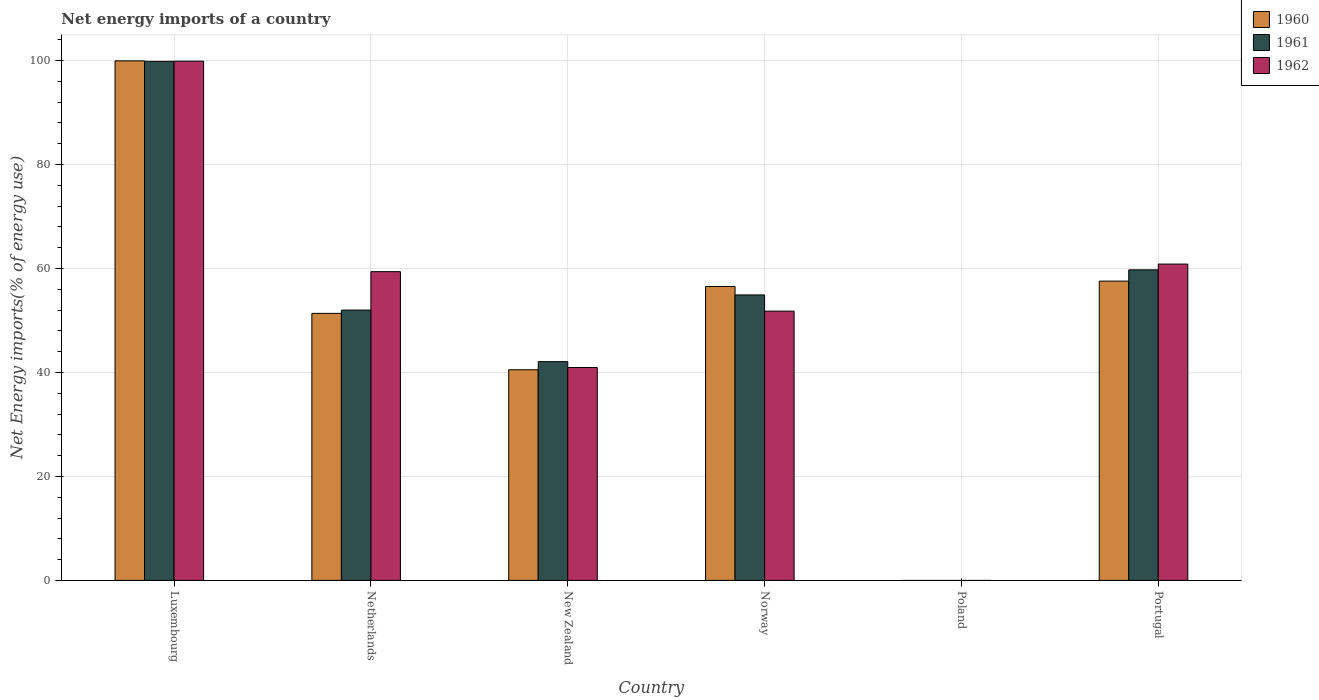How many different coloured bars are there?
Offer a very short reply. 3. Are the number of bars per tick equal to the number of legend labels?
Offer a terse response. No. How many bars are there on the 3rd tick from the left?
Your answer should be compact. 3. What is the label of the 1st group of bars from the left?
Offer a terse response. Luxembourg. In how many cases, is the number of bars for a given country not equal to the number of legend labels?
Your answer should be compact. 1. What is the net energy imports in 1961 in Netherlands?
Make the answer very short. 52. Across all countries, what is the maximum net energy imports in 1962?
Your response must be concise. 99.88. In which country was the net energy imports in 1961 maximum?
Your answer should be very brief. Luxembourg. What is the total net energy imports in 1962 in the graph?
Provide a succinct answer. 312.88. What is the difference between the net energy imports in 1961 in Netherlands and that in Portugal?
Give a very brief answer. -7.74. What is the difference between the net energy imports in 1962 in Norway and the net energy imports in 1961 in Portugal?
Provide a short and direct response. -7.94. What is the average net energy imports in 1961 per country?
Give a very brief answer. 51.43. What is the difference between the net energy imports of/in 1960 and net energy imports of/in 1961 in New Zealand?
Ensure brevity in your answer.  -1.56. In how many countries, is the net energy imports in 1961 greater than 32 %?
Keep it short and to the point. 5. What is the ratio of the net energy imports in 1962 in Luxembourg to that in Portugal?
Your response must be concise. 1.64. What is the difference between the highest and the second highest net energy imports in 1960?
Provide a short and direct response. -1.03. What is the difference between the highest and the lowest net energy imports in 1961?
Provide a succinct answer. 99.85. Is the sum of the net energy imports in 1962 in Luxembourg and Netherlands greater than the maximum net energy imports in 1960 across all countries?
Make the answer very short. Yes. How many countries are there in the graph?
Give a very brief answer. 6. What is the difference between two consecutive major ticks on the Y-axis?
Offer a very short reply. 20. Are the values on the major ticks of Y-axis written in scientific E-notation?
Offer a terse response. No. Does the graph contain any zero values?
Offer a terse response. Yes. Does the graph contain grids?
Your answer should be compact. Yes. What is the title of the graph?
Make the answer very short. Net energy imports of a country. Does "1966" appear as one of the legend labels in the graph?
Offer a very short reply. No. What is the label or title of the Y-axis?
Provide a short and direct response. Net Energy imports(% of energy use). What is the Net Energy imports(% of energy use) in 1960 in Luxembourg?
Ensure brevity in your answer.  99.95. What is the Net Energy imports(% of energy use) of 1961 in Luxembourg?
Offer a very short reply. 99.85. What is the Net Energy imports(% of energy use) of 1962 in Luxembourg?
Offer a terse response. 99.88. What is the Net Energy imports(% of energy use) in 1960 in Netherlands?
Give a very brief answer. 51.37. What is the Net Energy imports(% of energy use) in 1961 in Netherlands?
Your answer should be very brief. 52. What is the Net Energy imports(% of energy use) in 1962 in Netherlands?
Offer a terse response. 59.39. What is the Net Energy imports(% of energy use) in 1960 in New Zealand?
Provide a short and direct response. 40.52. What is the Net Energy imports(% of energy use) in 1961 in New Zealand?
Offer a terse response. 42.08. What is the Net Energy imports(% of energy use) in 1962 in New Zealand?
Make the answer very short. 40.95. What is the Net Energy imports(% of energy use) of 1960 in Norway?
Offer a very short reply. 56.54. What is the Net Energy imports(% of energy use) in 1961 in Norway?
Provide a short and direct response. 54.92. What is the Net Energy imports(% of energy use) of 1962 in Norway?
Give a very brief answer. 51.8. What is the Net Energy imports(% of energy use) in 1960 in Poland?
Your response must be concise. 0. What is the Net Energy imports(% of energy use) in 1961 in Poland?
Give a very brief answer. 0. What is the Net Energy imports(% of energy use) of 1960 in Portugal?
Make the answer very short. 57.57. What is the Net Energy imports(% of energy use) in 1961 in Portugal?
Your answer should be compact. 59.74. What is the Net Energy imports(% of energy use) of 1962 in Portugal?
Your answer should be very brief. 60.85. Across all countries, what is the maximum Net Energy imports(% of energy use) in 1960?
Your answer should be compact. 99.95. Across all countries, what is the maximum Net Energy imports(% of energy use) of 1961?
Your answer should be compact. 99.85. Across all countries, what is the maximum Net Energy imports(% of energy use) of 1962?
Give a very brief answer. 99.88. Across all countries, what is the minimum Net Energy imports(% of energy use) in 1960?
Give a very brief answer. 0. Across all countries, what is the minimum Net Energy imports(% of energy use) of 1961?
Offer a very short reply. 0. Across all countries, what is the minimum Net Energy imports(% of energy use) of 1962?
Keep it short and to the point. 0. What is the total Net Energy imports(% of energy use) of 1960 in the graph?
Make the answer very short. 305.95. What is the total Net Energy imports(% of energy use) of 1961 in the graph?
Provide a succinct answer. 308.6. What is the total Net Energy imports(% of energy use) of 1962 in the graph?
Give a very brief answer. 312.88. What is the difference between the Net Energy imports(% of energy use) in 1960 in Luxembourg and that in Netherlands?
Give a very brief answer. 48.58. What is the difference between the Net Energy imports(% of energy use) of 1961 in Luxembourg and that in Netherlands?
Give a very brief answer. 47.85. What is the difference between the Net Energy imports(% of energy use) in 1962 in Luxembourg and that in Netherlands?
Provide a succinct answer. 40.49. What is the difference between the Net Energy imports(% of energy use) of 1960 in Luxembourg and that in New Zealand?
Give a very brief answer. 59.43. What is the difference between the Net Energy imports(% of energy use) of 1961 in Luxembourg and that in New Zealand?
Give a very brief answer. 57.77. What is the difference between the Net Energy imports(% of energy use) in 1962 in Luxembourg and that in New Zealand?
Make the answer very short. 58.93. What is the difference between the Net Energy imports(% of energy use) in 1960 in Luxembourg and that in Norway?
Offer a terse response. 43.41. What is the difference between the Net Energy imports(% of energy use) of 1961 in Luxembourg and that in Norway?
Offer a very short reply. 44.94. What is the difference between the Net Energy imports(% of energy use) in 1962 in Luxembourg and that in Norway?
Offer a very short reply. 48.08. What is the difference between the Net Energy imports(% of energy use) in 1960 in Luxembourg and that in Portugal?
Your answer should be very brief. 42.37. What is the difference between the Net Energy imports(% of energy use) of 1961 in Luxembourg and that in Portugal?
Provide a short and direct response. 40.11. What is the difference between the Net Energy imports(% of energy use) in 1962 in Luxembourg and that in Portugal?
Ensure brevity in your answer.  39.03. What is the difference between the Net Energy imports(% of energy use) in 1960 in Netherlands and that in New Zealand?
Give a very brief answer. 10.85. What is the difference between the Net Energy imports(% of energy use) in 1961 in Netherlands and that in New Zealand?
Provide a short and direct response. 9.92. What is the difference between the Net Energy imports(% of energy use) of 1962 in Netherlands and that in New Zealand?
Provide a succinct answer. 18.44. What is the difference between the Net Energy imports(% of energy use) in 1960 in Netherlands and that in Norway?
Provide a succinct answer. -5.17. What is the difference between the Net Energy imports(% of energy use) in 1961 in Netherlands and that in Norway?
Offer a very short reply. -2.91. What is the difference between the Net Energy imports(% of energy use) of 1962 in Netherlands and that in Norway?
Your answer should be very brief. 7.59. What is the difference between the Net Energy imports(% of energy use) in 1960 in Netherlands and that in Portugal?
Your response must be concise. -6.21. What is the difference between the Net Energy imports(% of energy use) of 1961 in Netherlands and that in Portugal?
Keep it short and to the point. -7.74. What is the difference between the Net Energy imports(% of energy use) in 1962 in Netherlands and that in Portugal?
Make the answer very short. -1.46. What is the difference between the Net Energy imports(% of energy use) in 1960 in New Zealand and that in Norway?
Provide a succinct answer. -16.02. What is the difference between the Net Energy imports(% of energy use) in 1961 in New Zealand and that in Norway?
Make the answer very short. -12.83. What is the difference between the Net Energy imports(% of energy use) in 1962 in New Zealand and that in Norway?
Your response must be concise. -10.85. What is the difference between the Net Energy imports(% of energy use) of 1960 in New Zealand and that in Portugal?
Ensure brevity in your answer.  -17.05. What is the difference between the Net Energy imports(% of energy use) in 1961 in New Zealand and that in Portugal?
Your answer should be very brief. -17.66. What is the difference between the Net Energy imports(% of energy use) of 1962 in New Zealand and that in Portugal?
Make the answer very short. -19.9. What is the difference between the Net Energy imports(% of energy use) in 1960 in Norway and that in Portugal?
Offer a very short reply. -1.03. What is the difference between the Net Energy imports(% of energy use) in 1961 in Norway and that in Portugal?
Provide a succinct answer. -4.83. What is the difference between the Net Energy imports(% of energy use) of 1962 in Norway and that in Portugal?
Offer a very short reply. -9.05. What is the difference between the Net Energy imports(% of energy use) in 1960 in Luxembourg and the Net Energy imports(% of energy use) in 1961 in Netherlands?
Offer a terse response. 47.94. What is the difference between the Net Energy imports(% of energy use) in 1960 in Luxembourg and the Net Energy imports(% of energy use) in 1962 in Netherlands?
Provide a succinct answer. 40.56. What is the difference between the Net Energy imports(% of energy use) of 1961 in Luxembourg and the Net Energy imports(% of energy use) of 1962 in Netherlands?
Your response must be concise. 40.46. What is the difference between the Net Energy imports(% of energy use) in 1960 in Luxembourg and the Net Energy imports(% of energy use) in 1961 in New Zealand?
Offer a very short reply. 57.87. What is the difference between the Net Energy imports(% of energy use) in 1960 in Luxembourg and the Net Energy imports(% of energy use) in 1962 in New Zealand?
Ensure brevity in your answer.  58.99. What is the difference between the Net Energy imports(% of energy use) in 1961 in Luxembourg and the Net Energy imports(% of energy use) in 1962 in New Zealand?
Offer a terse response. 58.9. What is the difference between the Net Energy imports(% of energy use) in 1960 in Luxembourg and the Net Energy imports(% of energy use) in 1961 in Norway?
Provide a succinct answer. 45.03. What is the difference between the Net Energy imports(% of energy use) in 1960 in Luxembourg and the Net Energy imports(% of energy use) in 1962 in Norway?
Provide a short and direct response. 48.15. What is the difference between the Net Energy imports(% of energy use) of 1961 in Luxembourg and the Net Energy imports(% of energy use) of 1962 in Norway?
Your answer should be compact. 48.05. What is the difference between the Net Energy imports(% of energy use) in 1960 in Luxembourg and the Net Energy imports(% of energy use) in 1961 in Portugal?
Give a very brief answer. 40.21. What is the difference between the Net Energy imports(% of energy use) in 1960 in Luxembourg and the Net Energy imports(% of energy use) in 1962 in Portugal?
Ensure brevity in your answer.  39.09. What is the difference between the Net Energy imports(% of energy use) of 1961 in Luxembourg and the Net Energy imports(% of energy use) of 1962 in Portugal?
Provide a succinct answer. 39. What is the difference between the Net Energy imports(% of energy use) in 1960 in Netherlands and the Net Energy imports(% of energy use) in 1961 in New Zealand?
Provide a succinct answer. 9.29. What is the difference between the Net Energy imports(% of energy use) in 1960 in Netherlands and the Net Energy imports(% of energy use) in 1962 in New Zealand?
Offer a very short reply. 10.42. What is the difference between the Net Energy imports(% of energy use) of 1961 in Netherlands and the Net Energy imports(% of energy use) of 1962 in New Zealand?
Your answer should be compact. 11.05. What is the difference between the Net Energy imports(% of energy use) in 1960 in Netherlands and the Net Energy imports(% of energy use) in 1961 in Norway?
Ensure brevity in your answer.  -3.55. What is the difference between the Net Energy imports(% of energy use) in 1960 in Netherlands and the Net Energy imports(% of energy use) in 1962 in Norway?
Make the answer very short. -0.43. What is the difference between the Net Energy imports(% of energy use) of 1961 in Netherlands and the Net Energy imports(% of energy use) of 1962 in Norway?
Make the answer very short. 0.2. What is the difference between the Net Energy imports(% of energy use) of 1960 in Netherlands and the Net Energy imports(% of energy use) of 1961 in Portugal?
Make the answer very short. -8.37. What is the difference between the Net Energy imports(% of energy use) of 1960 in Netherlands and the Net Energy imports(% of energy use) of 1962 in Portugal?
Ensure brevity in your answer.  -9.49. What is the difference between the Net Energy imports(% of energy use) in 1961 in Netherlands and the Net Energy imports(% of energy use) in 1962 in Portugal?
Your answer should be very brief. -8.85. What is the difference between the Net Energy imports(% of energy use) of 1960 in New Zealand and the Net Energy imports(% of energy use) of 1961 in Norway?
Make the answer very short. -14.39. What is the difference between the Net Energy imports(% of energy use) in 1960 in New Zealand and the Net Energy imports(% of energy use) in 1962 in Norway?
Offer a very short reply. -11.28. What is the difference between the Net Energy imports(% of energy use) of 1961 in New Zealand and the Net Energy imports(% of energy use) of 1962 in Norway?
Your answer should be very brief. -9.72. What is the difference between the Net Energy imports(% of energy use) in 1960 in New Zealand and the Net Energy imports(% of energy use) in 1961 in Portugal?
Provide a short and direct response. -19.22. What is the difference between the Net Energy imports(% of energy use) in 1960 in New Zealand and the Net Energy imports(% of energy use) in 1962 in Portugal?
Your answer should be compact. -20.33. What is the difference between the Net Energy imports(% of energy use) of 1961 in New Zealand and the Net Energy imports(% of energy use) of 1962 in Portugal?
Keep it short and to the point. -18.77. What is the difference between the Net Energy imports(% of energy use) in 1960 in Norway and the Net Energy imports(% of energy use) in 1961 in Portugal?
Your response must be concise. -3.2. What is the difference between the Net Energy imports(% of energy use) in 1960 in Norway and the Net Energy imports(% of energy use) in 1962 in Portugal?
Offer a very short reply. -4.31. What is the difference between the Net Energy imports(% of energy use) in 1961 in Norway and the Net Energy imports(% of energy use) in 1962 in Portugal?
Give a very brief answer. -5.94. What is the average Net Energy imports(% of energy use) of 1960 per country?
Keep it short and to the point. 50.99. What is the average Net Energy imports(% of energy use) of 1961 per country?
Provide a short and direct response. 51.43. What is the average Net Energy imports(% of energy use) of 1962 per country?
Keep it short and to the point. 52.15. What is the difference between the Net Energy imports(% of energy use) of 1960 and Net Energy imports(% of energy use) of 1961 in Luxembourg?
Make the answer very short. 0.09. What is the difference between the Net Energy imports(% of energy use) in 1960 and Net Energy imports(% of energy use) in 1962 in Luxembourg?
Your answer should be very brief. 0.06. What is the difference between the Net Energy imports(% of energy use) in 1961 and Net Energy imports(% of energy use) in 1962 in Luxembourg?
Keep it short and to the point. -0.03. What is the difference between the Net Energy imports(% of energy use) of 1960 and Net Energy imports(% of energy use) of 1961 in Netherlands?
Your answer should be compact. -0.64. What is the difference between the Net Energy imports(% of energy use) in 1960 and Net Energy imports(% of energy use) in 1962 in Netherlands?
Keep it short and to the point. -8.02. What is the difference between the Net Energy imports(% of energy use) in 1961 and Net Energy imports(% of energy use) in 1962 in Netherlands?
Keep it short and to the point. -7.39. What is the difference between the Net Energy imports(% of energy use) in 1960 and Net Energy imports(% of energy use) in 1961 in New Zealand?
Give a very brief answer. -1.56. What is the difference between the Net Energy imports(% of energy use) in 1960 and Net Energy imports(% of energy use) in 1962 in New Zealand?
Provide a short and direct response. -0.43. What is the difference between the Net Energy imports(% of energy use) of 1961 and Net Energy imports(% of energy use) of 1962 in New Zealand?
Provide a short and direct response. 1.13. What is the difference between the Net Energy imports(% of energy use) in 1960 and Net Energy imports(% of energy use) in 1961 in Norway?
Ensure brevity in your answer.  1.62. What is the difference between the Net Energy imports(% of energy use) of 1960 and Net Energy imports(% of energy use) of 1962 in Norway?
Offer a terse response. 4.74. What is the difference between the Net Energy imports(% of energy use) in 1961 and Net Energy imports(% of energy use) in 1962 in Norway?
Make the answer very short. 3.12. What is the difference between the Net Energy imports(% of energy use) of 1960 and Net Energy imports(% of energy use) of 1961 in Portugal?
Ensure brevity in your answer.  -2.17. What is the difference between the Net Energy imports(% of energy use) of 1960 and Net Energy imports(% of energy use) of 1962 in Portugal?
Keep it short and to the point. -3.28. What is the difference between the Net Energy imports(% of energy use) of 1961 and Net Energy imports(% of energy use) of 1962 in Portugal?
Keep it short and to the point. -1.11. What is the ratio of the Net Energy imports(% of energy use) of 1960 in Luxembourg to that in Netherlands?
Offer a terse response. 1.95. What is the ratio of the Net Energy imports(% of energy use) in 1961 in Luxembourg to that in Netherlands?
Ensure brevity in your answer.  1.92. What is the ratio of the Net Energy imports(% of energy use) of 1962 in Luxembourg to that in Netherlands?
Offer a terse response. 1.68. What is the ratio of the Net Energy imports(% of energy use) in 1960 in Luxembourg to that in New Zealand?
Ensure brevity in your answer.  2.47. What is the ratio of the Net Energy imports(% of energy use) in 1961 in Luxembourg to that in New Zealand?
Your answer should be compact. 2.37. What is the ratio of the Net Energy imports(% of energy use) in 1962 in Luxembourg to that in New Zealand?
Provide a succinct answer. 2.44. What is the ratio of the Net Energy imports(% of energy use) in 1960 in Luxembourg to that in Norway?
Your answer should be very brief. 1.77. What is the ratio of the Net Energy imports(% of energy use) in 1961 in Luxembourg to that in Norway?
Your answer should be very brief. 1.82. What is the ratio of the Net Energy imports(% of energy use) of 1962 in Luxembourg to that in Norway?
Your response must be concise. 1.93. What is the ratio of the Net Energy imports(% of energy use) in 1960 in Luxembourg to that in Portugal?
Your answer should be very brief. 1.74. What is the ratio of the Net Energy imports(% of energy use) of 1961 in Luxembourg to that in Portugal?
Make the answer very short. 1.67. What is the ratio of the Net Energy imports(% of energy use) in 1962 in Luxembourg to that in Portugal?
Make the answer very short. 1.64. What is the ratio of the Net Energy imports(% of energy use) of 1960 in Netherlands to that in New Zealand?
Provide a short and direct response. 1.27. What is the ratio of the Net Energy imports(% of energy use) in 1961 in Netherlands to that in New Zealand?
Offer a very short reply. 1.24. What is the ratio of the Net Energy imports(% of energy use) of 1962 in Netherlands to that in New Zealand?
Offer a very short reply. 1.45. What is the ratio of the Net Energy imports(% of energy use) of 1960 in Netherlands to that in Norway?
Your response must be concise. 0.91. What is the ratio of the Net Energy imports(% of energy use) in 1961 in Netherlands to that in Norway?
Keep it short and to the point. 0.95. What is the ratio of the Net Energy imports(% of energy use) in 1962 in Netherlands to that in Norway?
Keep it short and to the point. 1.15. What is the ratio of the Net Energy imports(% of energy use) of 1960 in Netherlands to that in Portugal?
Offer a very short reply. 0.89. What is the ratio of the Net Energy imports(% of energy use) of 1961 in Netherlands to that in Portugal?
Your answer should be very brief. 0.87. What is the ratio of the Net Energy imports(% of energy use) in 1962 in Netherlands to that in Portugal?
Give a very brief answer. 0.98. What is the ratio of the Net Energy imports(% of energy use) in 1960 in New Zealand to that in Norway?
Your answer should be compact. 0.72. What is the ratio of the Net Energy imports(% of energy use) of 1961 in New Zealand to that in Norway?
Provide a short and direct response. 0.77. What is the ratio of the Net Energy imports(% of energy use) in 1962 in New Zealand to that in Norway?
Your answer should be compact. 0.79. What is the ratio of the Net Energy imports(% of energy use) of 1960 in New Zealand to that in Portugal?
Make the answer very short. 0.7. What is the ratio of the Net Energy imports(% of energy use) of 1961 in New Zealand to that in Portugal?
Provide a short and direct response. 0.7. What is the ratio of the Net Energy imports(% of energy use) in 1962 in New Zealand to that in Portugal?
Your answer should be very brief. 0.67. What is the ratio of the Net Energy imports(% of energy use) in 1960 in Norway to that in Portugal?
Provide a short and direct response. 0.98. What is the ratio of the Net Energy imports(% of energy use) of 1961 in Norway to that in Portugal?
Offer a very short reply. 0.92. What is the ratio of the Net Energy imports(% of energy use) in 1962 in Norway to that in Portugal?
Offer a terse response. 0.85. What is the difference between the highest and the second highest Net Energy imports(% of energy use) in 1960?
Provide a succinct answer. 42.37. What is the difference between the highest and the second highest Net Energy imports(% of energy use) of 1961?
Provide a short and direct response. 40.11. What is the difference between the highest and the second highest Net Energy imports(% of energy use) in 1962?
Keep it short and to the point. 39.03. What is the difference between the highest and the lowest Net Energy imports(% of energy use) in 1960?
Your answer should be very brief. 99.95. What is the difference between the highest and the lowest Net Energy imports(% of energy use) of 1961?
Give a very brief answer. 99.85. What is the difference between the highest and the lowest Net Energy imports(% of energy use) of 1962?
Your response must be concise. 99.88. 